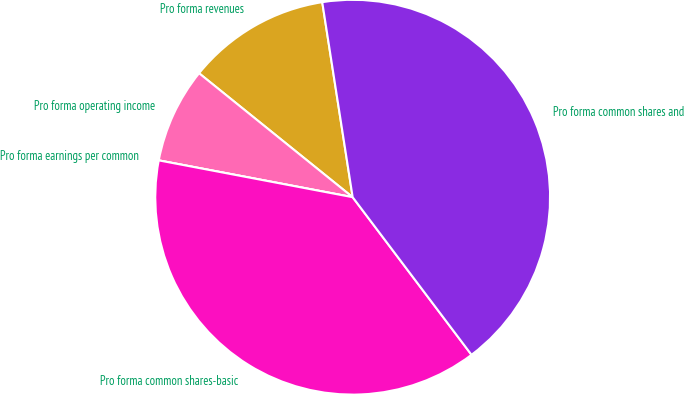Convert chart. <chart><loc_0><loc_0><loc_500><loc_500><pie_chart><fcel>Pro forma revenues<fcel>Pro forma operating income<fcel>Pro forma earnings per common<fcel>Pro forma common shares-basic<fcel>Pro forma common shares and<nl><fcel>11.73%<fcel>7.82%<fcel>0.0%<fcel>38.27%<fcel>42.18%<nl></chart> 